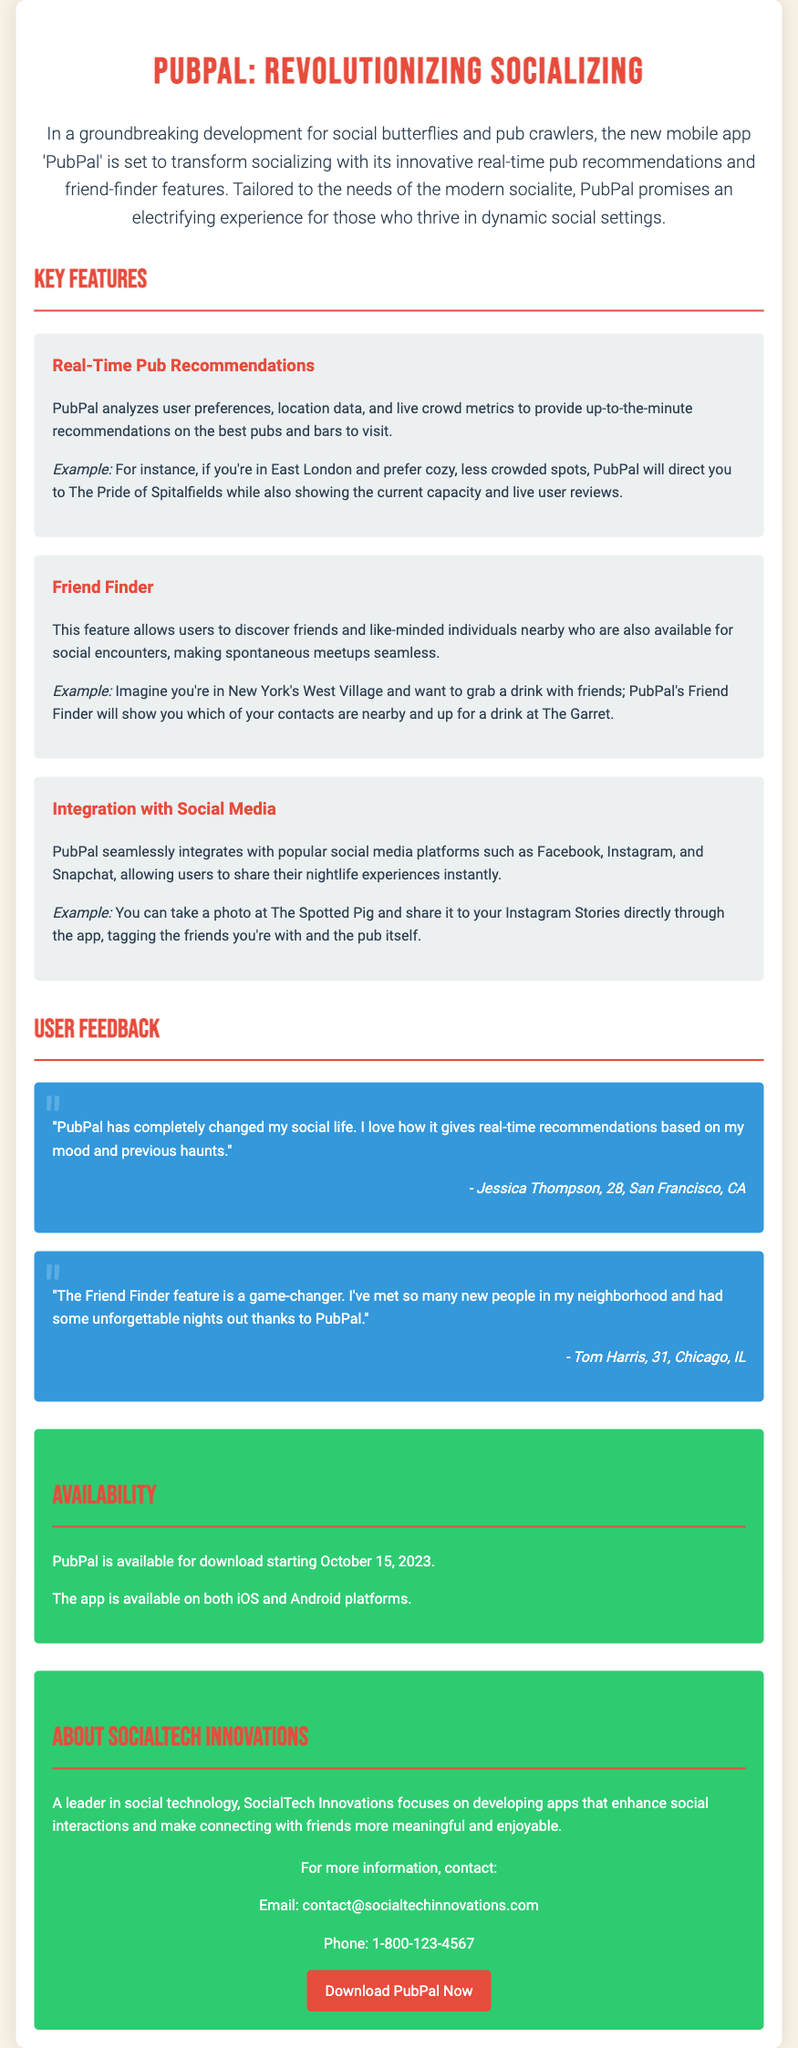What is the name of the app? The name of the app is mentioned in the title and introduction of the press release.
Answer: PubPal What feature does PubPal use to recommend pubs? This feature analyzes user preferences and location data to recommend pubs.
Answer: Real-Time Pub Recommendations When will PubPal be available for download? The availability date is specified in the document under the Availability section.
Answer: October 15, 2023 Which social media platforms does PubPal integrate with? The integrations are clearly mentioned in the features section of the document.
Answer: Facebook, Instagram, Snapchat Who is the target audience for PubPal? The target audience is described in the introduction of the press release.
Answer: Modern socialite What is the testimonial from Jessica Thompson about? The testimonial expresses a specific sentiment about the app's impact on social life.
Answer: Changed my social life How does the Friend Finder feature operate? The operation is explained in the feature section detailing how users can meet new people.
Answer: Discover friends nearby What type of company is SocialTech Innovations? The document describes the company's focus and expertise in the About section.
Answer: Leader in social technology 